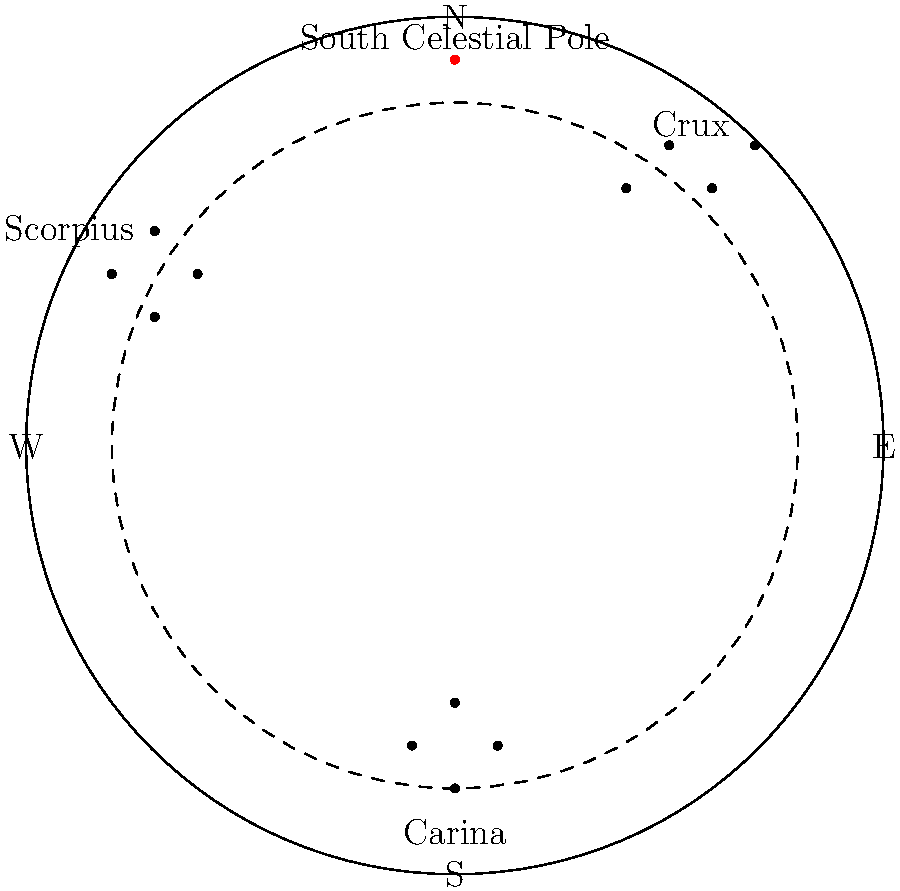Using the star chart provided, which constellation visible from Argentina could help you locate the South Celestial Pole, similar to how Polaris indicates the North Celestial Pole in the Northern Hemisphere? To answer this question, let's follow these steps:

1. Observe the star chart, which represents the night sky as seen from Argentina in the Southern Hemisphere.

2. Notice that the chart shows three main constellations: Crux, Scorpius, and Carina.

3. The South Celestial Pole is marked on the chart, similar to how Polaris indicates the North Celestial Pole in the Northern Hemisphere.

4. Among the constellations shown, Crux (also known as the Southern Cross) is the key to finding the South Celestial Pole.

5. The longer axis of Crux points directly towards the South Celestial Pole.

6. This method of using Crux to locate the South Celestial Pole is widely used in celestial navigation in the Southern Hemisphere, similar to how Polaris is used in the Northern Hemisphere.

7. Neither Scorpius nor Carina directly point to the South Celestial Pole in the same way that Crux does.

Therefore, the constellation Crux (Southern Cross) is the one that helps locate the South Celestial Pole from Argentina.
Answer: Crux (Southern Cross) 